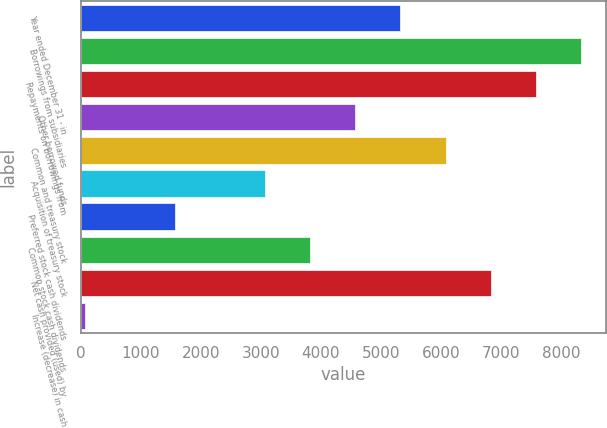Convert chart to OTSL. <chart><loc_0><loc_0><loc_500><loc_500><bar_chart><fcel>Year ended December 31 - in<fcel>Borrowings from subsidiaries<fcel>Repayments on borrowings from<fcel>Other borrowed funds<fcel>Common and treasury stock<fcel>Acquisition of treasury stock<fcel>Preferred stock cash dividends<fcel>Common stock cash dividends<fcel>Net cash provided (used) by<fcel>Increase (decrease) in cash<nl><fcel>5325.5<fcel>8331.5<fcel>7580<fcel>4574<fcel>6077<fcel>3071<fcel>1568<fcel>3822.5<fcel>6828.5<fcel>65<nl></chart> 